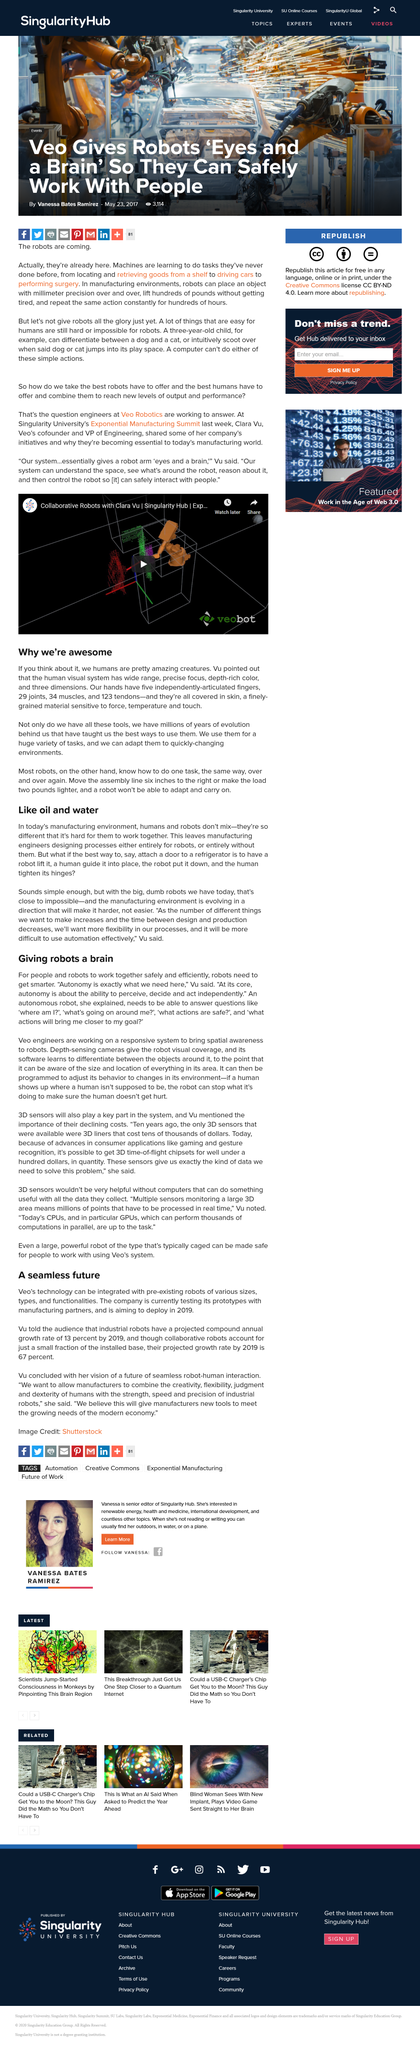Specify some key components in this picture. In order for people and robots to work together safely and efficiently, it is necessary for robots to become smarter and more capable of understanding and responding to human behavior and intentions. The human visual system is capable of interpreting three dimensions. By 2019, it is projected that the compound annual growth rate of industrial robots will be 13 percent. The manufacturing environment is evolving in such a way that it is becoming increasingly difficult. According to the article "A seamless future," the projected growth rate of industrial robots by 2019 is expected to be 67 percent. 